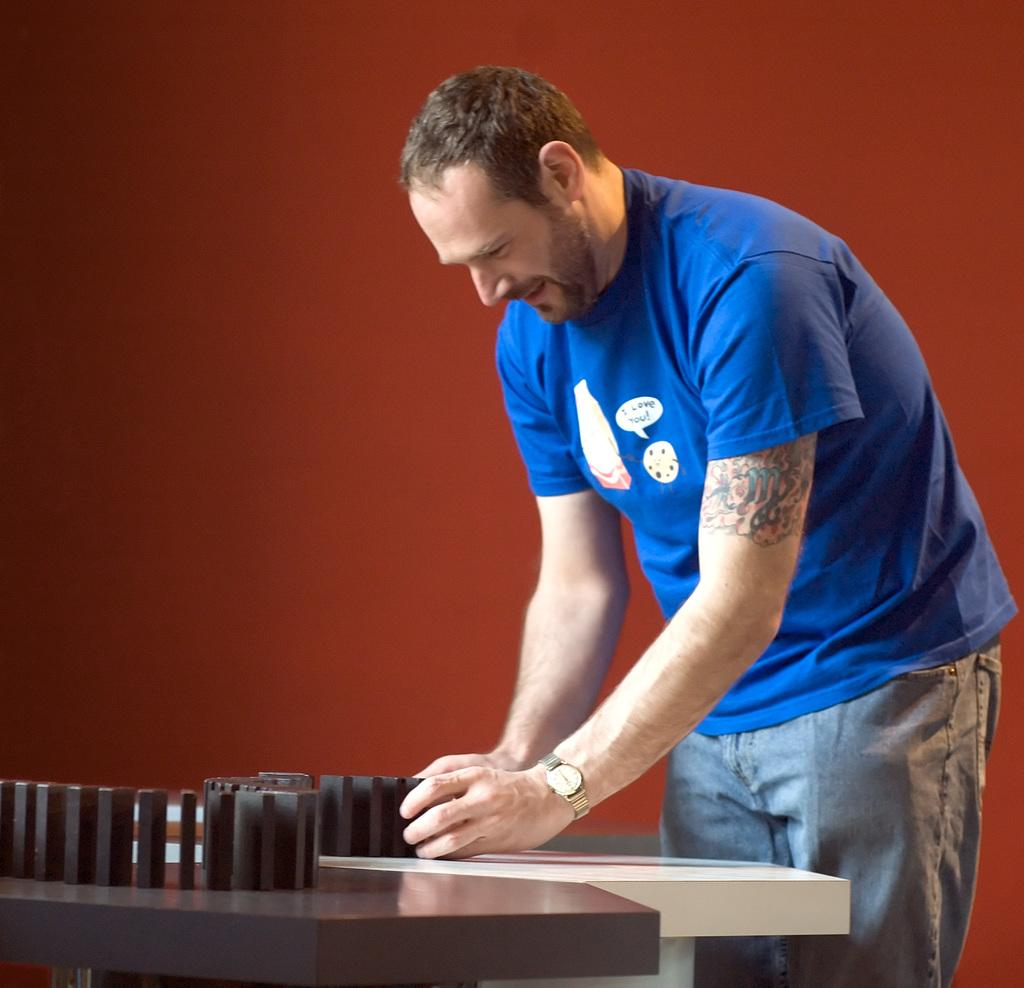What is the main subject in the image? There is a person standing in the image. What is present in the image besides the person? There is a table in the image. What can be seen on the table? There are objects on the table. Can you describe the background of the image? The background of the image has a color. What type of shirt is the horse wearing in the image? There is no horse or shirt present in the image. 